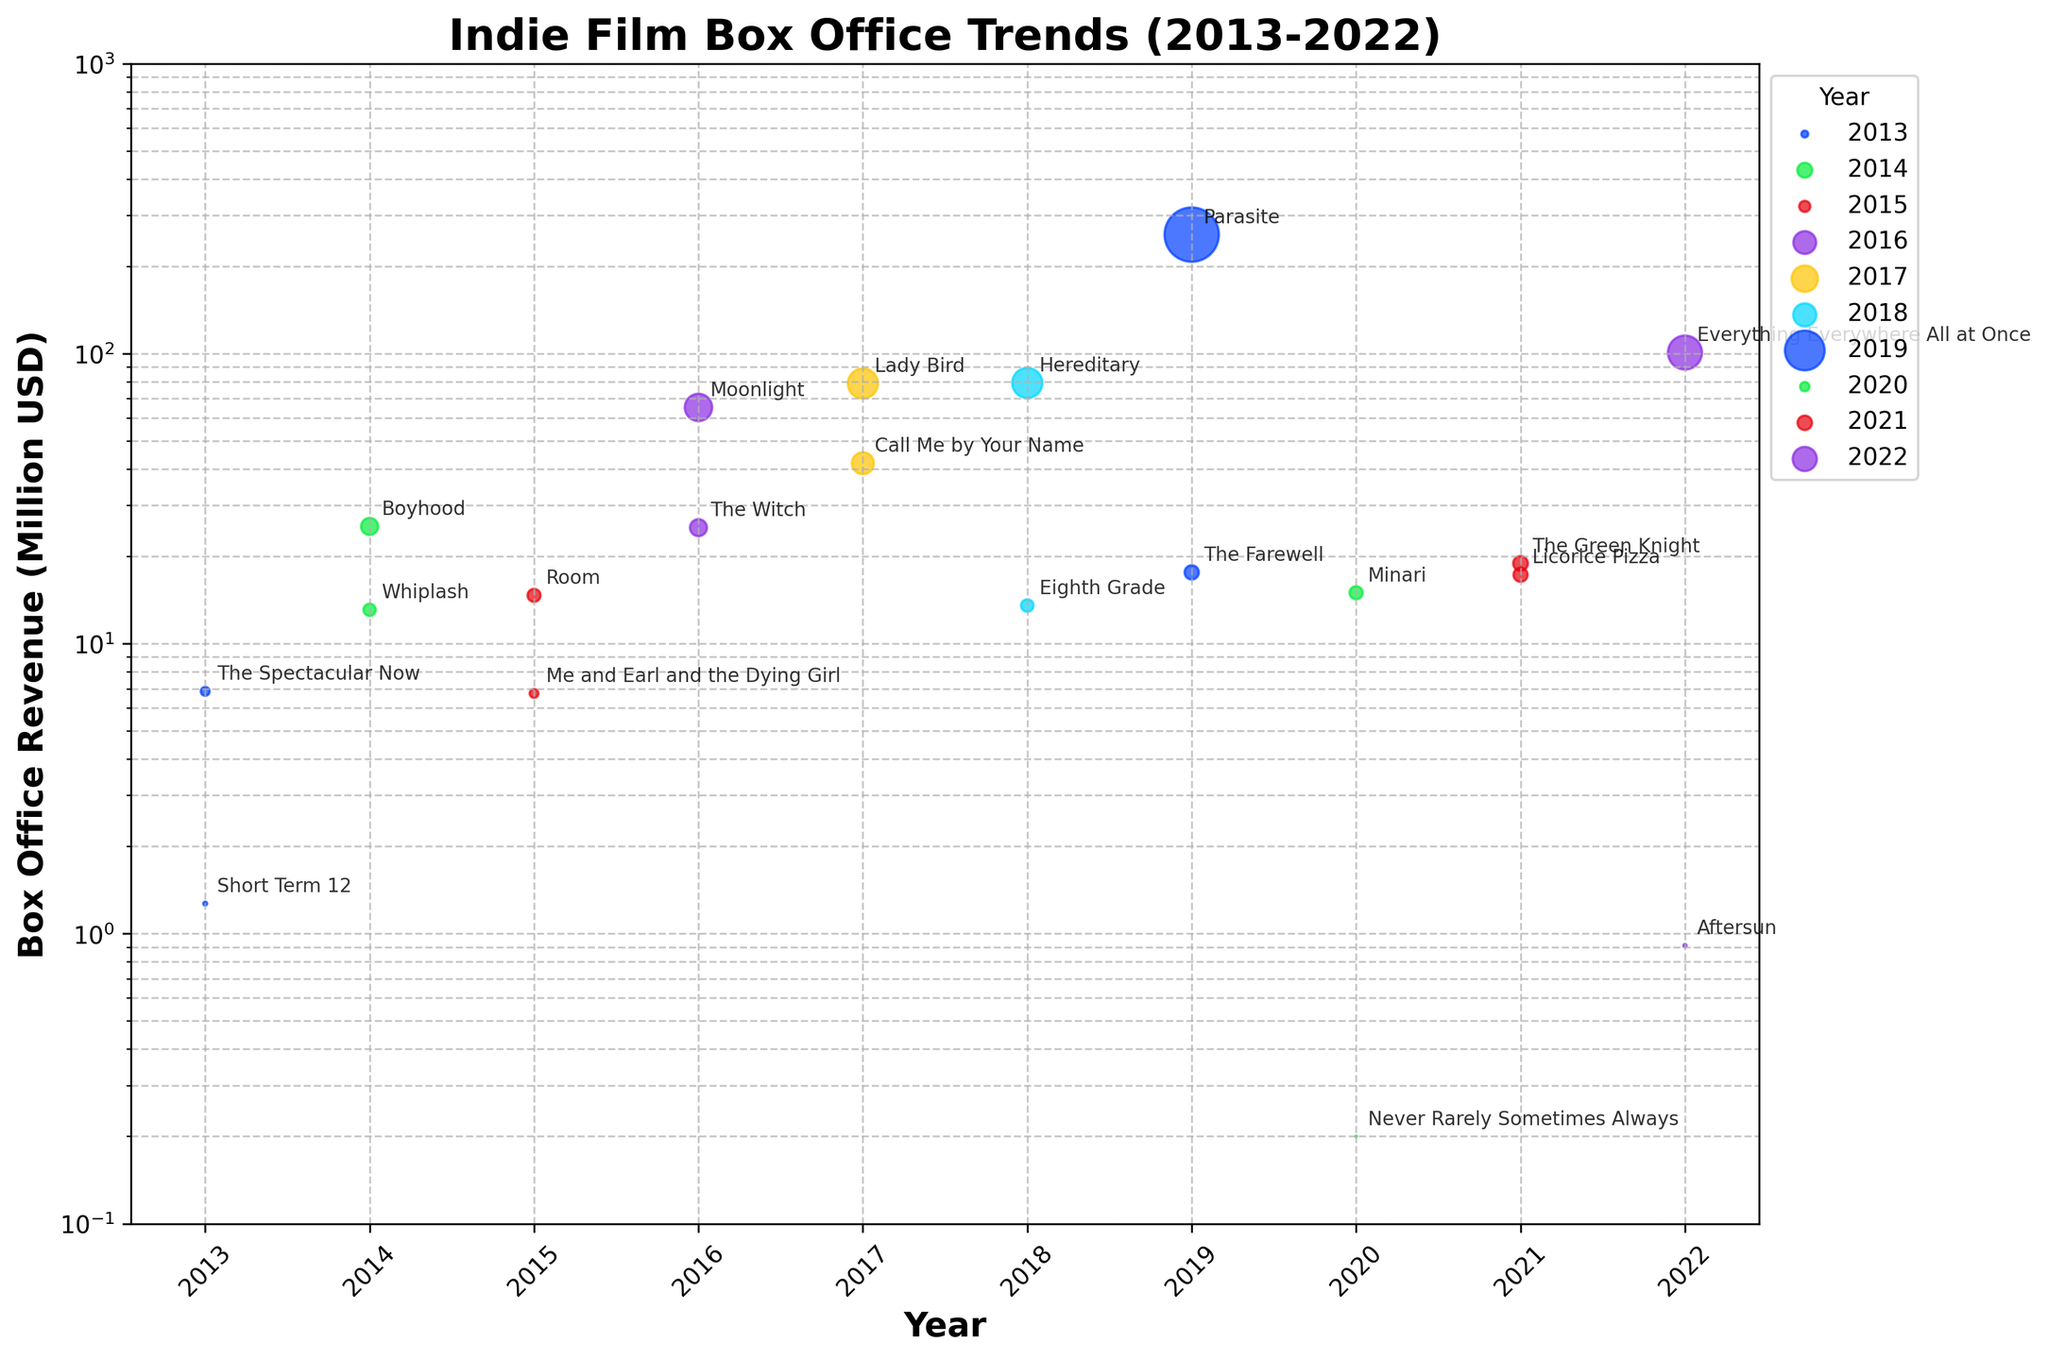What's the title of the figure? The title is displayed prominently at the top of the figure.
Answer: Indie Film Box Office Trends (2013-2022) Which year had the highest box office revenue for a single film? By observing the vertical axis and the data points, 2019 had the highest box office revenue with "Parasite" making 257.55 million USD.
Answer: 2019 How many films made over 50 million USD in box office revenue? By counting the number of data points on the figure that are above the 50 million USD mark, we find that there are four films: "Moonlight," "Lady Bird," "Hereditary," and "Parasite."
Answer: Four What is the range of box office revenue for films in 2020? By looking at the data points for the year 2020, we identify the lowest and highest revenues: "Never Rarely Sometimes Always" with 0.2 million USD and "Minari" with 14.99 million USD. The range is 14.99 - 0.2 = 14.79 million USD.
Answer: 14.79 million USD Which film had the lowest box office revenue and in which year? The smallest data point on the y-axis corresponds to "Never Rarely Sometimes Always" in 2020 with 0.2 million USD.
Answer: Never Rarely Sometimes Always, 2020 Compare the box office revenue of "Whiplash" and "Moonlight." Which film earned more and by how much? "Whiplash" made 13.09 million USD in 2014, and "Moonlight" made 65.30 million USD in 2016. The difference is 65.30 - 13.09 = 52.21 million USD. "Moonlight" earned more by 52.21 million USD.
Answer: Moonlight, 52.21 million USD Which year had the most number of films included in the plot? By counting the number of data points per year, we see that 2017 stands out with two films ("Call Me by Your Name" and "Lady Bird"). Though there are multiple years with two films, a quick scan shows that unlike others, 2017 had both films with high box office revenues.
Answer: 2017 What is the median box office revenue of the films released in 2022? For 2022, the box office revenues are 100.97 million USD and 0.91 million USD. The median of these two values is (100.97 + 0.91) / 2 = 50.94 million USD.
Answer: 50.94 million USD Which film had the highest box office revenue in 2017, and how much was it? By observing the data points and the details for the films in 2017, "Lady Bird" had the highest box office revenue with 78.95 million USD.
Answer: Lady Bird, 78.95 million USD 